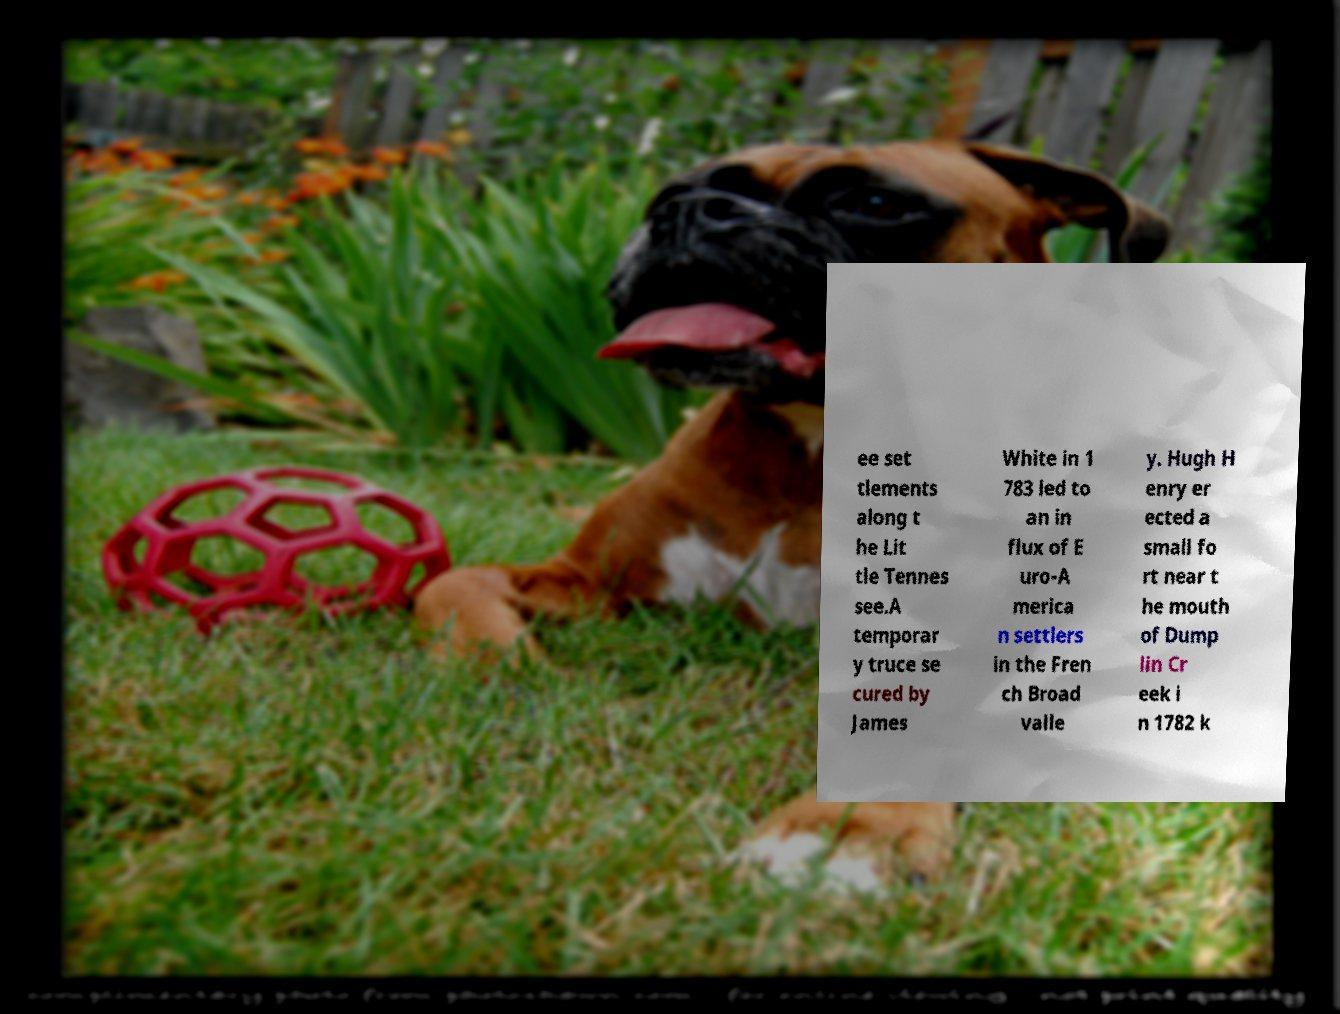Could you assist in decoding the text presented in this image and type it out clearly? ee set tlements along t he Lit tle Tennes see.A temporar y truce se cured by James White in 1 783 led to an in flux of E uro-A merica n settlers in the Fren ch Broad valle y. Hugh H enry er ected a small fo rt near t he mouth of Dump lin Cr eek i n 1782 k 